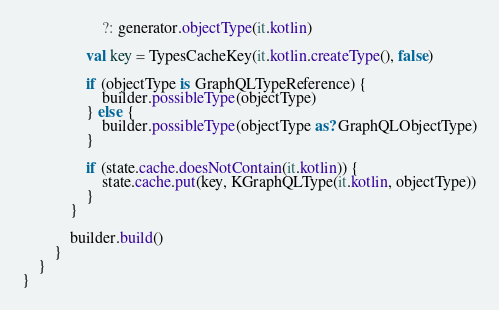<code> <loc_0><loc_0><loc_500><loc_500><_Kotlin_>                    ?: generator.objectType(it.kotlin)

                val key = TypesCacheKey(it.kotlin.createType(), false)

                if (objectType is GraphQLTypeReference) {
                    builder.possibleType(objectType)
                } else {
                    builder.possibleType(objectType as? GraphQLObjectType)
                }

                if (state.cache.doesNotContain(it.kotlin)) {
                    state.cache.put(key, KGraphQLType(it.kotlin, objectType))
                }
            }

            builder.build()
        }
    }
}
</code> 